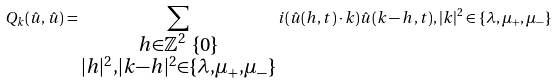<formula> <loc_0><loc_0><loc_500><loc_500>Q _ { k } ( \hat { u } , \hat { u } ) = \sum _ { \substack { h \in \mathbb { Z } ^ { 2 } \ \{ 0 \} \\ | h | ^ { 2 } , | k - h | ^ { 2 } \in \{ \lambda , \mu _ { + } , \mu _ { - } \} } } i ( \hat { u } ( h , t ) \cdot k ) \hat { u } ( k - h , t ) , | k | ^ { 2 } \in \{ \lambda , \mu _ { + } , \mu _ { - } \}</formula> 